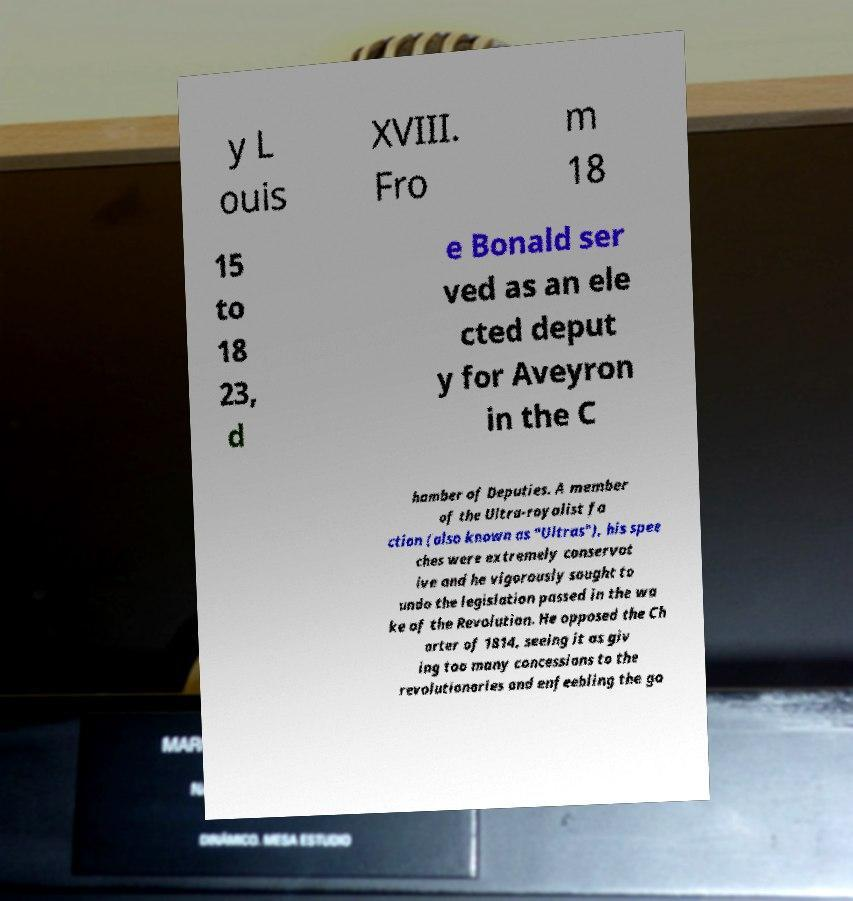Can you accurately transcribe the text from the provided image for me? y L ouis XVIII. Fro m 18 15 to 18 23, d e Bonald ser ved as an ele cted deput y for Aveyron in the C hamber of Deputies. A member of the Ultra-royalist fa ction (also known as "Ultras"), his spee ches were extremely conservat ive and he vigorously sought to undo the legislation passed in the wa ke of the Revolution. He opposed the Ch arter of 1814, seeing it as giv ing too many concessions to the revolutionaries and enfeebling the go 